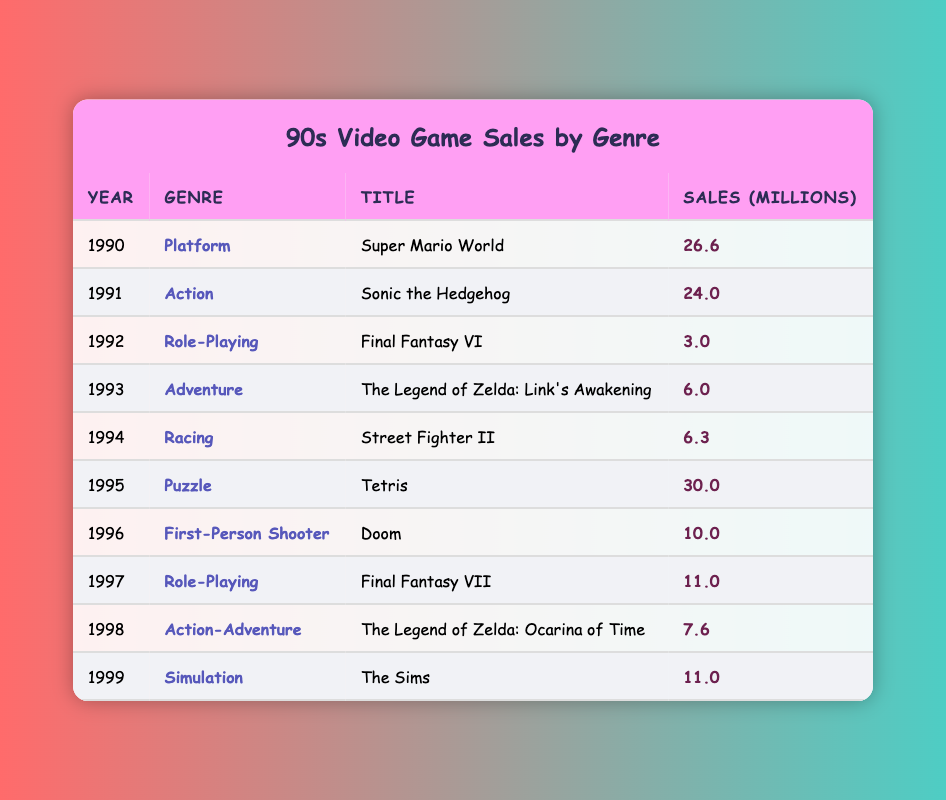What was the highest-selling game in the 1990s? The highest-selling game can be found by comparing the SalesInMillions values for all titles. The game "Tetris" from 1995 had sales of 30.0 million, which is the highest compared to other entries in the table.
Answer: Tetris Which genre had the most games listed in the table? By examining the Genre column, we identify the different genres and count their occurrences. Each of the listed genres appears only once in the table, so there are no genres with multiple titles. Thus, they all have an equal count of one.
Answer: Each genre appears once In which year did "Final Fantasy VII" release, and what were its sales? From the table, we look for the row containing "Final Fantasy VII," which is listed under the year 1997 with sales of 11.0 million. This can be easily retrieved by simply locating that specific row.
Answer: 1997, 11.0 million What is the average sales of all the video games listed? To find the average sales, we first sum all the sales figures: 26.6 + 24.0 + 3.0 + 6.0 + 6.3 + 30.0 + 10.0 + 11.0 + 7.6 + 11.0 =  128.5 million. There are 10 games in total, thus the average is 128.5 / 10 = 12.85 million.
Answer: 12.85 million Did any Role-Playing genre game sell more than 10 million copies? Checking the sales figures for the Role-Playing genre, "Final Fantasy VI" sold 3.0 million, and "Final Fantasy VII" sold 11.0 million. Since 11.0 million is greater than 10 million, the statement is true.
Answer: Yes 